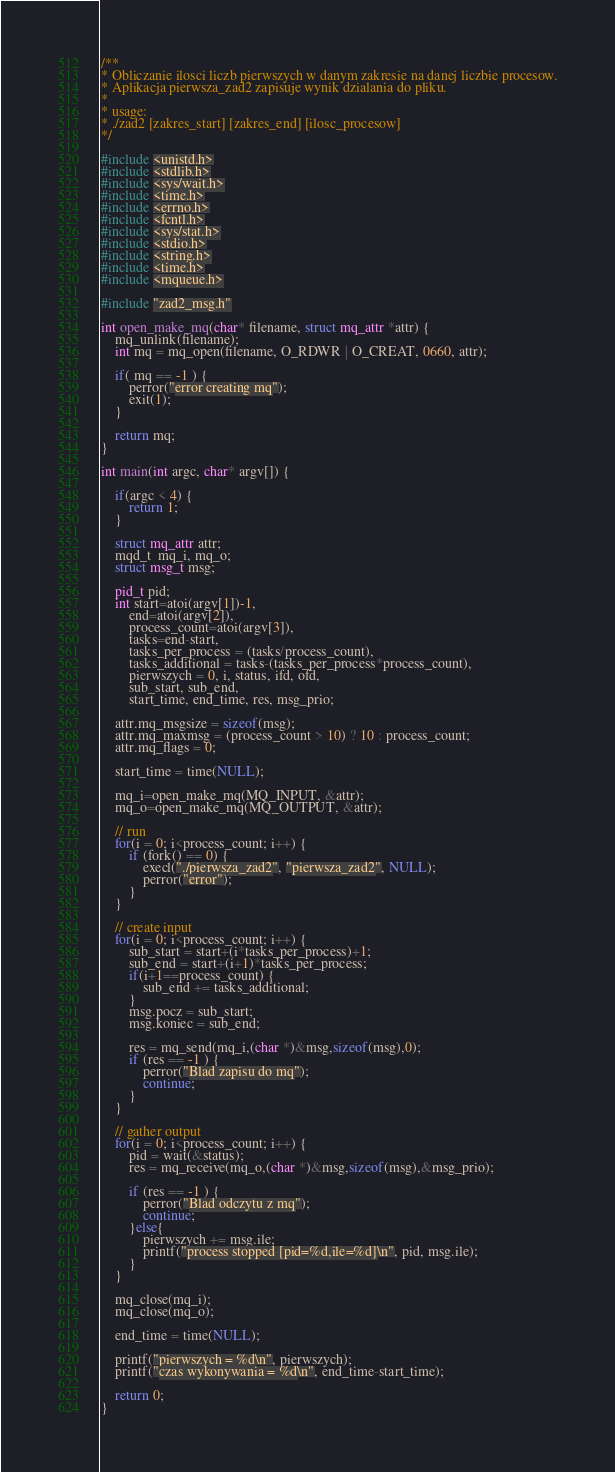<code> <loc_0><loc_0><loc_500><loc_500><_C_>/**
* Obliczanie ilosci liczb pierwszych w danym zakresie na danej liczbie procesow.
* Aplikacja pierwsza_zad2 zapisuje wynik dzialania do pliku.
*
* usage:
* ./zad2 [zakres_start] [zakres_end] [ilosc_procesow]
*/

#include <unistd.h>
#include <stdlib.h>
#include <sys/wait.h>
#include <time.h>
#include <errno.h>
#include <fcntl.h>
#include <sys/stat.h>
#include <stdio.h>
#include <string.h>
#include <time.h>
#include <mqueue.h>

#include "zad2_msg.h"
    
int open_make_mq(char* filename, struct mq_attr *attr) {
    mq_unlink(filename);
    int mq = mq_open(filename, O_RDWR | O_CREAT, 0660, attr);
    
    if( mq == -1 ) {
        perror("error creating mq");
        exit(1);
    }
    
    return mq; 
}

int main(int argc, char* argv[]) {

    if(argc < 4) {
        return 1;
    }
    
    struct mq_attr attr;
    mqd_t  mq_i, mq_o;
    struct msg_t msg;
    
    pid_t pid;
    int start=atoi(argv[1])-1,
        end=atoi(argv[2]),
        process_count=atoi(argv[3]),
        tasks=end-start,
        tasks_per_process = (tasks/process_count),
        tasks_additional = tasks-(tasks_per_process*process_count),
        pierwszych = 0, i, status, ifd, ofd,
        sub_start, sub_end,
        start_time, end_time, res, msg_prio;

    attr.mq_msgsize = sizeof(msg);
    attr.mq_maxmsg = (process_count > 10) ? 10 : process_count;
    attr.mq_flags = 0;

    start_time = time(NULL);

    mq_i=open_make_mq(MQ_INPUT, &attr);
    mq_o=open_make_mq(MQ_OUTPUT, &attr);
    
    // run 
    for(i = 0; i<process_count; i++) {
        if (fork() == 0) {
            execl("./pierwsza_zad2", "pierwsza_zad2", NULL);
            perror("error");
        }
    }

    // create input
    for(i = 0; i<process_count; i++) {
        sub_start = start+(i*tasks_per_process)+1;
        sub_end = start+(i+1)*tasks_per_process;
        if(i+1==process_count) {
            sub_end += tasks_additional;
        }
        msg.pocz = sub_start;
        msg.koniec = sub_end;
        
        res = mq_send(mq_i,(char *)&msg,sizeof(msg),0);
        if (res == -1 ) {
            perror("Blad zapisu do mq");
            continue;
        }
    }

    // gather output
    for(i = 0; i<process_count; i++) {
        pid = wait(&status);
        res = mq_receive(mq_o,(char *)&msg,sizeof(msg),&msg_prio);
        
        if (res == -1 ) {
            perror("Blad odczytu z mq");
            continue;
        }else{
            pierwszych += msg.ile;
            printf("process stopped [pid=%d,ile=%d]\n", pid, msg.ile);
        }
    }

    mq_close(mq_i);
    mq_close(mq_o);

    end_time = time(NULL);

    printf("pierwszych = %d\n", pierwszych);
    printf("czas wykonywania = %d\n", end_time-start_time);

    return 0;
}

</code> 